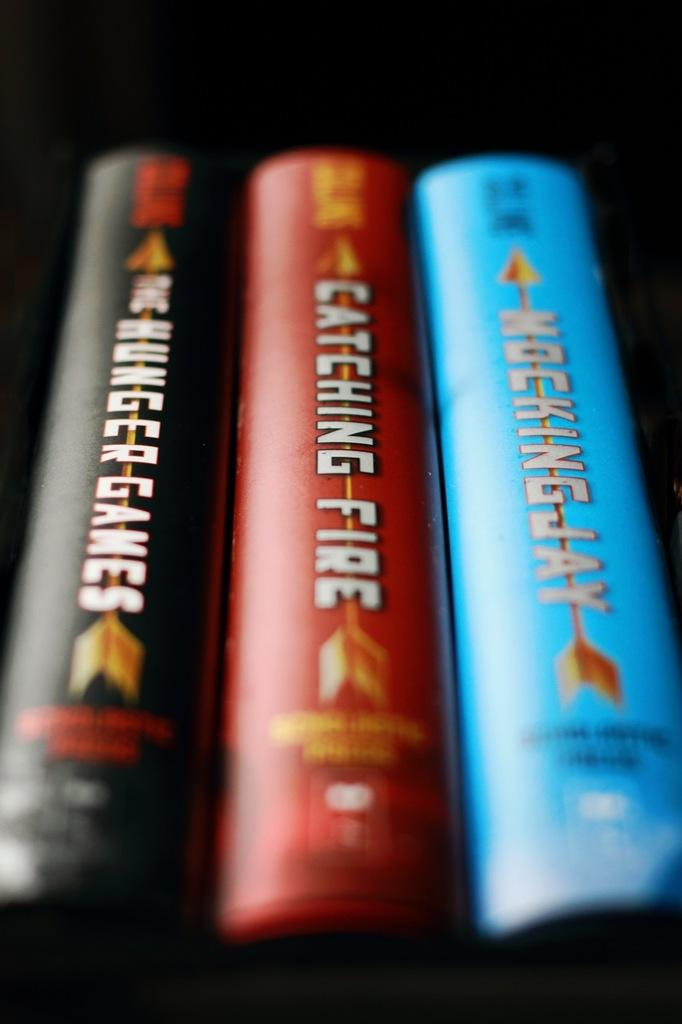<image>
Offer a succinct explanation of the picture presented. A stack of three book with one titled Catching Fire. 